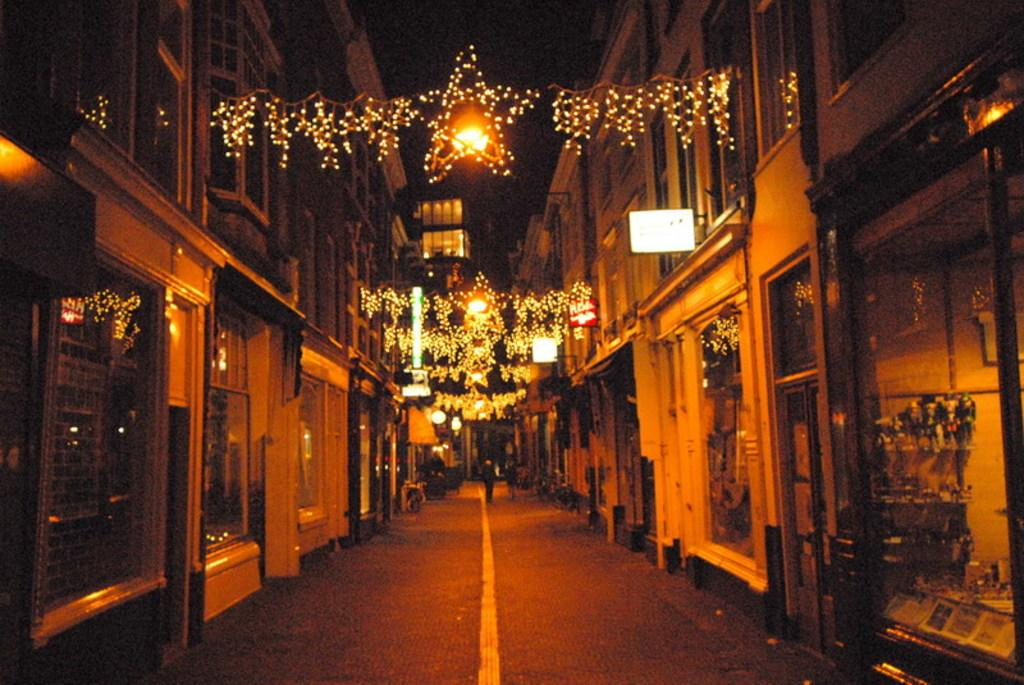What is the main feature of the image? There is a road in the image. What are the two persons on the road doing? The two persons are walking on the road. What can be seen on either side of the road? There are buildings on either side of the road. What is visible at the top of the image? There is lighting visible at the top of the image. What time of day is it at the school in the image? There is no school present in the image, so it is not possible to determine the time of day at a school. 